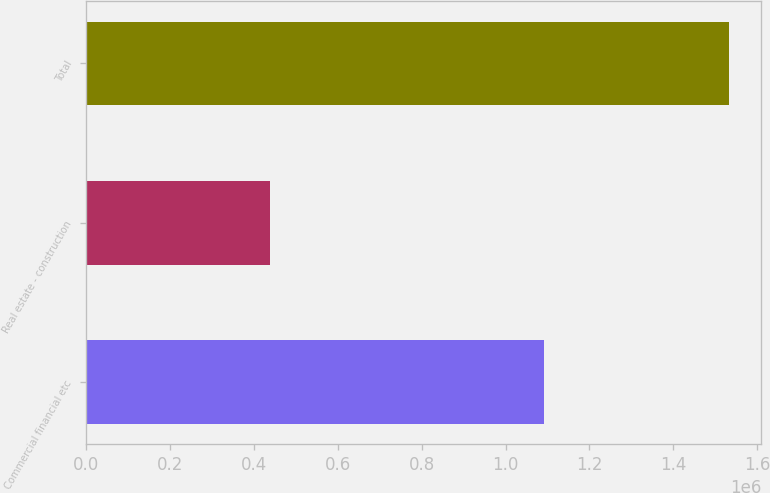<chart> <loc_0><loc_0><loc_500><loc_500><bar_chart><fcel>Commercial financial etc<fcel>Real estate - construction<fcel>Total<nl><fcel>1.09273e+06<fcel>439580<fcel>1.53231e+06<nl></chart> 